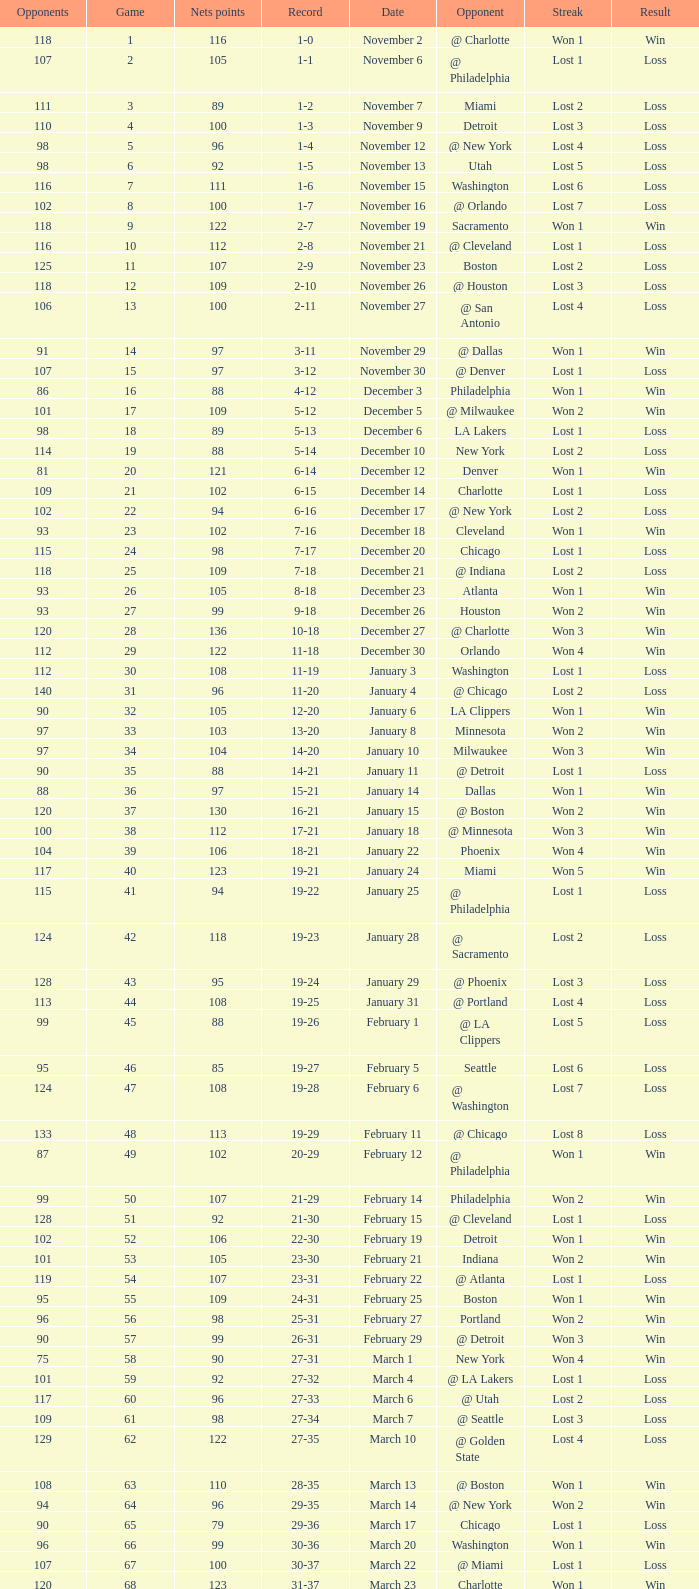How many opponents were there in a game higher than 20 on January 28? 124.0. 